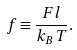Convert formula to latex. <formula><loc_0><loc_0><loc_500><loc_500>f \equiv \frac { F l } { k _ { B } T } .</formula> 